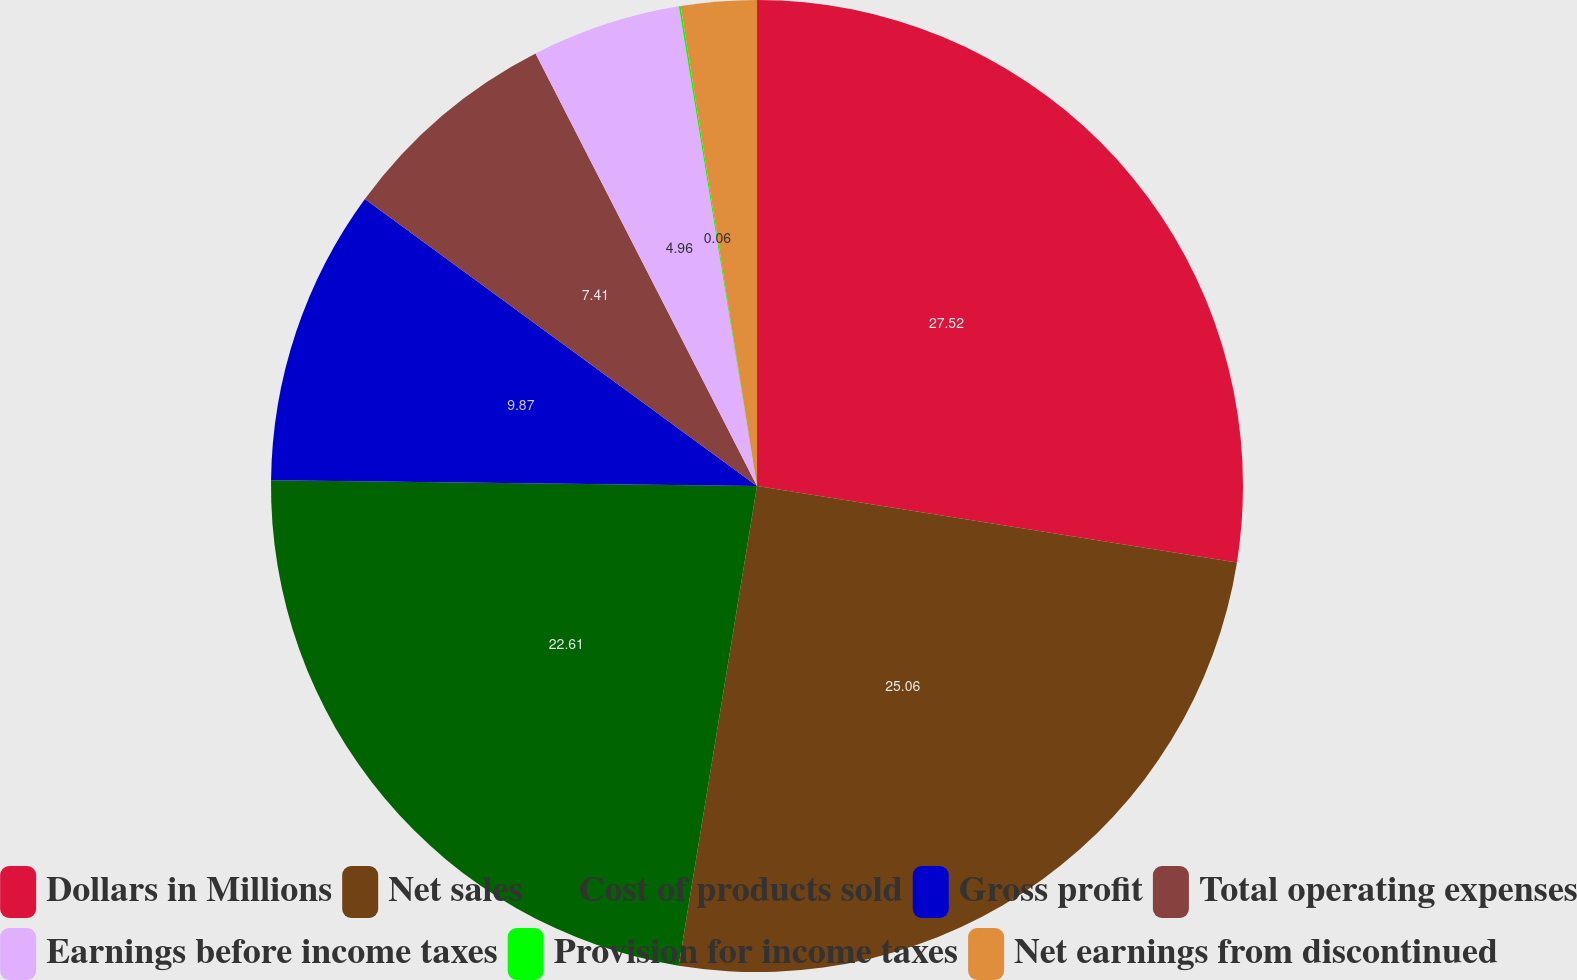Convert chart to OTSL. <chart><loc_0><loc_0><loc_500><loc_500><pie_chart><fcel>Dollars in Millions<fcel>Net sales<fcel>Cost of products sold<fcel>Gross profit<fcel>Total operating expenses<fcel>Earnings before income taxes<fcel>Provision for income taxes<fcel>Net earnings from discontinued<nl><fcel>27.51%<fcel>25.06%<fcel>22.61%<fcel>9.87%<fcel>7.41%<fcel>4.96%<fcel>0.06%<fcel>2.51%<nl></chart> 